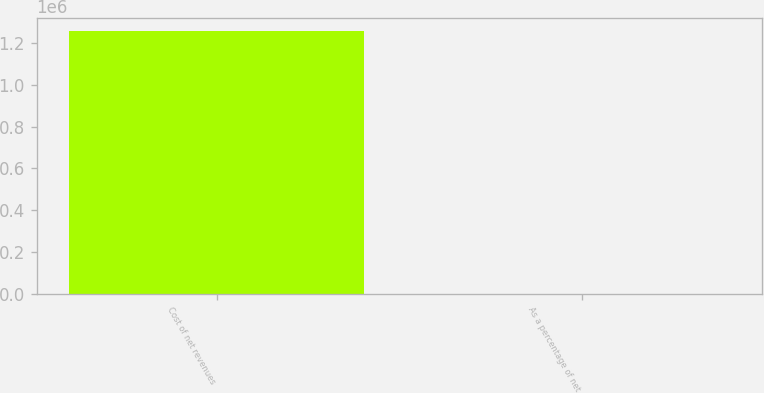Convert chart to OTSL. <chart><loc_0><loc_0><loc_500><loc_500><bar_chart><fcel>Cost of net revenues<fcel>As a percentage of net<nl><fcel>1.25679e+06<fcel>21.1<nl></chart> 